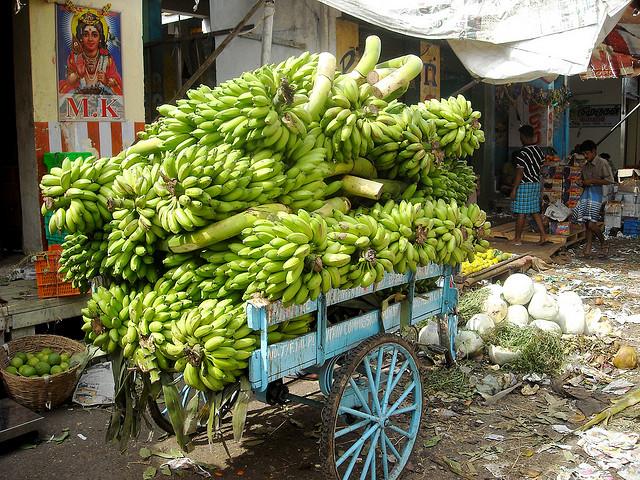What color fruit is in the wicker basket in the left corner?
Be succinct. Green. Is the fruit in the cart ripe?
Answer briefly. No. Are the bananas ripe?
Give a very brief answer. No. Is this in Alaska?
Concise answer only. No. 